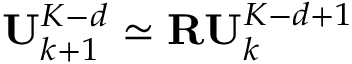<formula> <loc_0><loc_0><loc_500><loc_500>U _ { k + 1 } ^ { K - d } \simeq R U _ { k } ^ { K - d + 1 }</formula> 